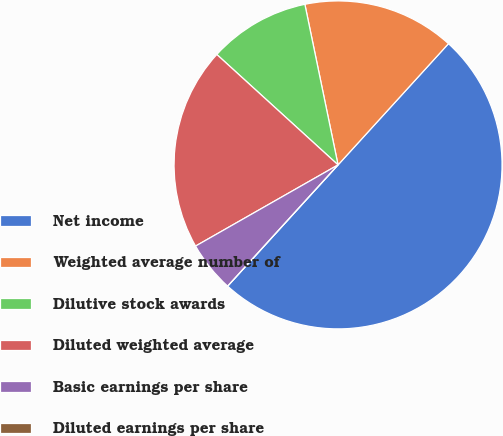<chart> <loc_0><loc_0><loc_500><loc_500><pie_chart><fcel>Net income<fcel>Weighted average number of<fcel>Dilutive stock awards<fcel>Diluted weighted average<fcel>Basic earnings per share<fcel>Diluted earnings per share<nl><fcel>50.0%<fcel>15.0%<fcel>10.0%<fcel>20.0%<fcel>5.0%<fcel>0.0%<nl></chart> 